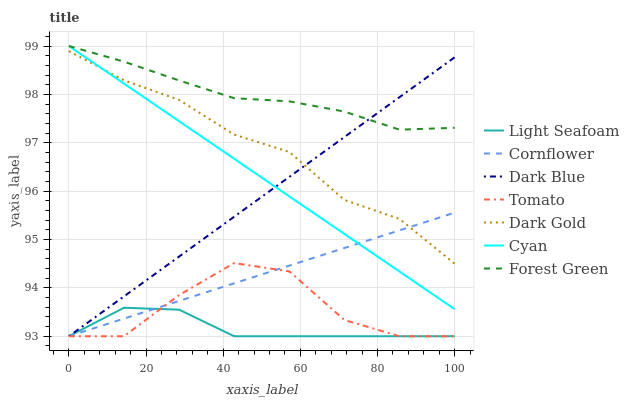Does Light Seafoam have the minimum area under the curve?
Answer yes or no. Yes. Does Forest Green have the maximum area under the curve?
Answer yes or no. Yes. Does Cornflower have the minimum area under the curve?
Answer yes or no. No. Does Cornflower have the maximum area under the curve?
Answer yes or no. No. Is Cyan the smoothest?
Answer yes or no. Yes. Is Tomato the roughest?
Answer yes or no. Yes. Is Cornflower the smoothest?
Answer yes or no. No. Is Cornflower the roughest?
Answer yes or no. No. Does Tomato have the lowest value?
Answer yes or no. Yes. Does Dark Gold have the lowest value?
Answer yes or no. No. Does Cyan have the highest value?
Answer yes or no. Yes. Does Cornflower have the highest value?
Answer yes or no. No. Is Tomato less than Cyan?
Answer yes or no. Yes. Is Dark Gold greater than Tomato?
Answer yes or no. Yes. Does Dark Blue intersect Cornflower?
Answer yes or no. Yes. Is Dark Blue less than Cornflower?
Answer yes or no. No. Is Dark Blue greater than Cornflower?
Answer yes or no. No. Does Tomato intersect Cyan?
Answer yes or no. No. 